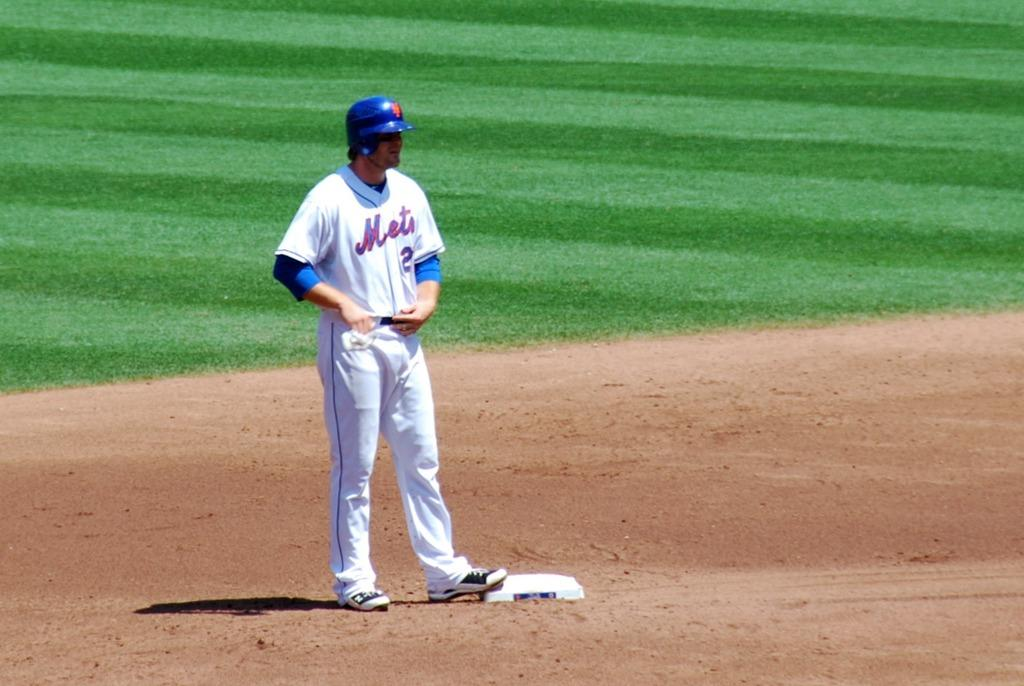<image>
Create a compact narrative representing the image presented. Baseball player for the Mets standing at plate. 